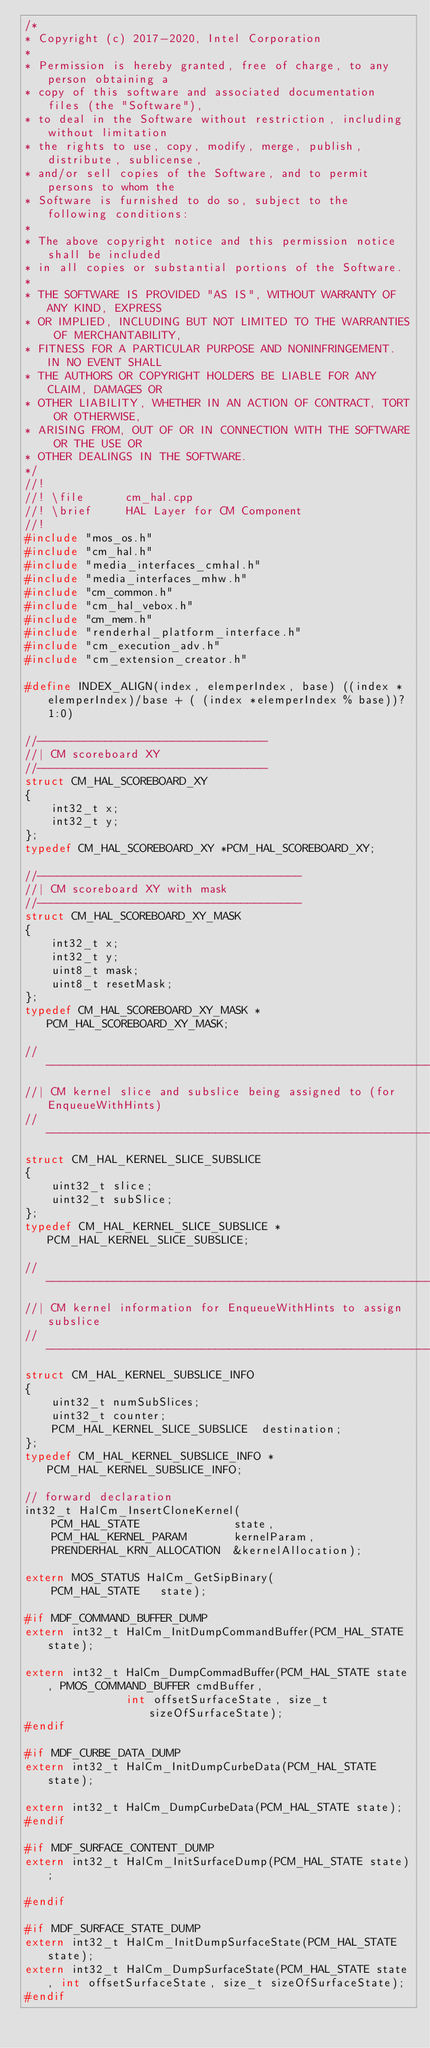Convert code to text. <code><loc_0><loc_0><loc_500><loc_500><_C++_>/*
* Copyright (c) 2017-2020, Intel Corporation
*
* Permission is hereby granted, free of charge, to any person obtaining a
* copy of this software and associated documentation files (the "Software"),
* to deal in the Software without restriction, including without limitation
* the rights to use, copy, modify, merge, publish, distribute, sublicense,
* and/or sell copies of the Software, and to permit persons to whom the
* Software is furnished to do so, subject to the following conditions:
*
* The above copyright notice and this permission notice shall be included
* in all copies or substantial portions of the Software.
*
* THE SOFTWARE IS PROVIDED "AS IS", WITHOUT WARRANTY OF ANY KIND, EXPRESS
* OR IMPLIED, INCLUDING BUT NOT LIMITED TO THE WARRANTIES OF MERCHANTABILITY,
* FITNESS FOR A PARTICULAR PURPOSE AND NONINFRINGEMENT. IN NO EVENT SHALL
* THE AUTHORS OR COPYRIGHT HOLDERS BE LIABLE FOR ANY CLAIM, DAMAGES OR
* OTHER LIABILITY, WHETHER IN AN ACTION OF CONTRACT, TORT OR OTHERWISE,
* ARISING FROM, OUT OF OR IN CONNECTION WITH THE SOFTWARE OR THE USE OR
* OTHER DEALINGS IN THE SOFTWARE.
*/
//!
//! \file      cm_hal.cpp
//! \brief     HAL Layer for CM Component
//!
#include "mos_os.h"
#include "cm_hal.h"
#include "media_interfaces_cmhal.h"
#include "media_interfaces_mhw.h"
#include "cm_common.h"
#include "cm_hal_vebox.h"
#include "cm_mem.h"
#include "renderhal_platform_interface.h"
#include "cm_execution_adv.h"
#include "cm_extension_creator.h"

#define INDEX_ALIGN(index, elemperIndex, base) ((index * elemperIndex)/base + ( (index *elemperIndex % base))? 1:0)

//----------------------------------
//| CM scoreboard XY
//----------------------------------
struct CM_HAL_SCOREBOARD_XY
{
    int32_t x;
    int32_t y;
};
typedef CM_HAL_SCOREBOARD_XY *PCM_HAL_SCOREBOARD_XY;

//---------------------------------------
//| CM scoreboard XY with mask
//---------------------------------------
struct CM_HAL_SCOREBOARD_XY_MASK
{
    int32_t x;
    int32_t y;
    uint8_t mask;
    uint8_t resetMask;
};
typedef CM_HAL_SCOREBOARD_XY_MASK *PCM_HAL_SCOREBOARD_XY_MASK;

//------------------------------------------------------------------------------
//| CM kernel slice and subslice being assigned to (for EnqueueWithHints)
//------------------------------------------------------------------------------
struct CM_HAL_KERNEL_SLICE_SUBSLICE
{
    uint32_t slice;
    uint32_t subSlice;
};
typedef CM_HAL_KERNEL_SLICE_SUBSLICE *PCM_HAL_KERNEL_SLICE_SUBSLICE;

//------------------------------------------------------------------------------
//| CM kernel information for EnqueueWithHints to assign subslice
//------------------------------------------------------------------------------
struct CM_HAL_KERNEL_SUBSLICE_INFO
{
    uint32_t numSubSlices;
    uint32_t counter;
    PCM_HAL_KERNEL_SLICE_SUBSLICE  destination;
};
typedef CM_HAL_KERNEL_SUBSLICE_INFO *PCM_HAL_KERNEL_SUBSLICE_INFO;

// forward declaration
int32_t HalCm_InsertCloneKernel(
    PCM_HAL_STATE              state,
    PCM_HAL_KERNEL_PARAM       kernelParam,
    PRENDERHAL_KRN_ALLOCATION  &kernelAllocation);

extern MOS_STATUS HalCm_GetSipBinary(
    PCM_HAL_STATE   state);

#if MDF_COMMAND_BUFFER_DUMP
extern int32_t HalCm_InitDumpCommandBuffer(PCM_HAL_STATE state);

extern int32_t HalCm_DumpCommadBuffer(PCM_HAL_STATE state, PMOS_COMMAND_BUFFER cmdBuffer,
               int offsetSurfaceState, size_t sizeOfSurfaceState);
#endif

#if MDF_CURBE_DATA_DUMP
extern int32_t HalCm_InitDumpCurbeData(PCM_HAL_STATE state);

extern int32_t HalCm_DumpCurbeData(PCM_HAL_STATE state);
#endif

#if MDF_SURFACE_CONTENT_DUMP
extern int32_t HalCm_InitSurfaceDump(PCM_HAL_STATE state);

#endif

#if MDF_SURFACE_STATE_DUMP
extern int32_t HalCm_InitDumpSurfaceState(PCM_HAL_STATE state);
extern int32_t HalCm_DumpSurfaceState(PCM_HAL_STATE state, int offsetSurfaceState, size_t sizeOfSurfaceState);
#endif
</code> 